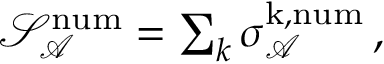Convert formula to latex. <formula><loc_0><loc_0><loc_500><loc_500>\begin{array} { r } { \mathcal { S } _ { \mathcal { A } } ^ { n u m } = \sum _ { k } \sigma _ { \mathcal { A } } ^ { k , n u m } \, , } \end{array}</formula> 